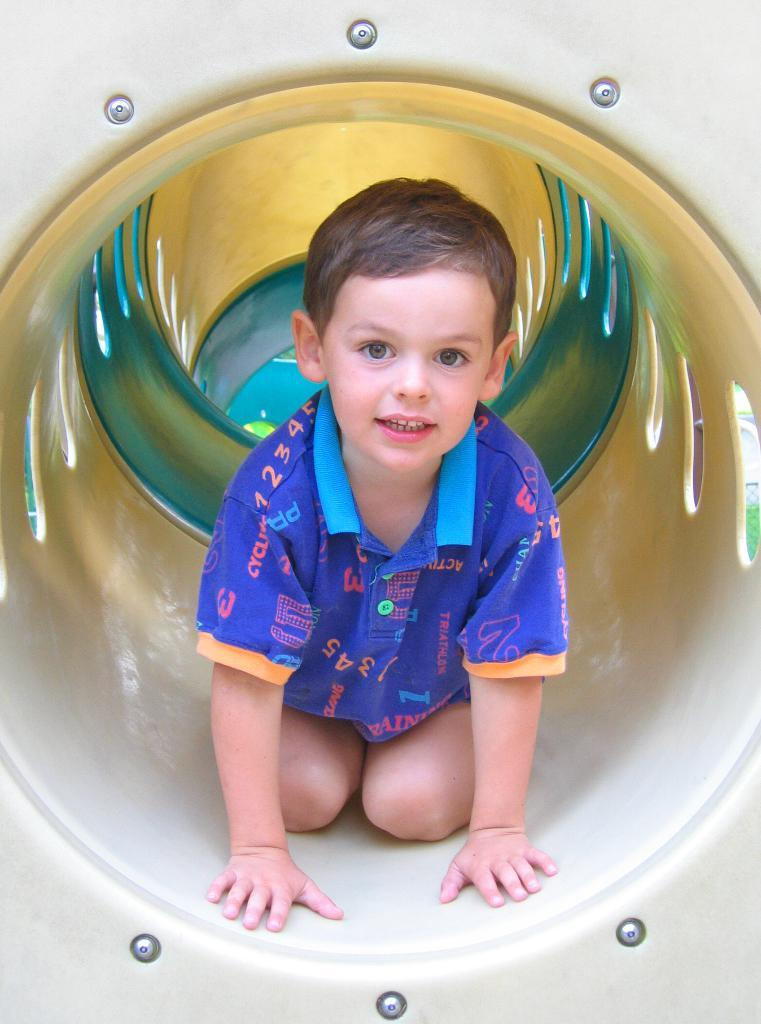What is the main subject of subject of the image? The main subject of the image is a kid. Where is the kid located in the image? The kid is inside a tunnel. What type of milk is the kid drinking while inside the tunnel? There is no milk present in the image, and the kid is not shown drinking anything. 